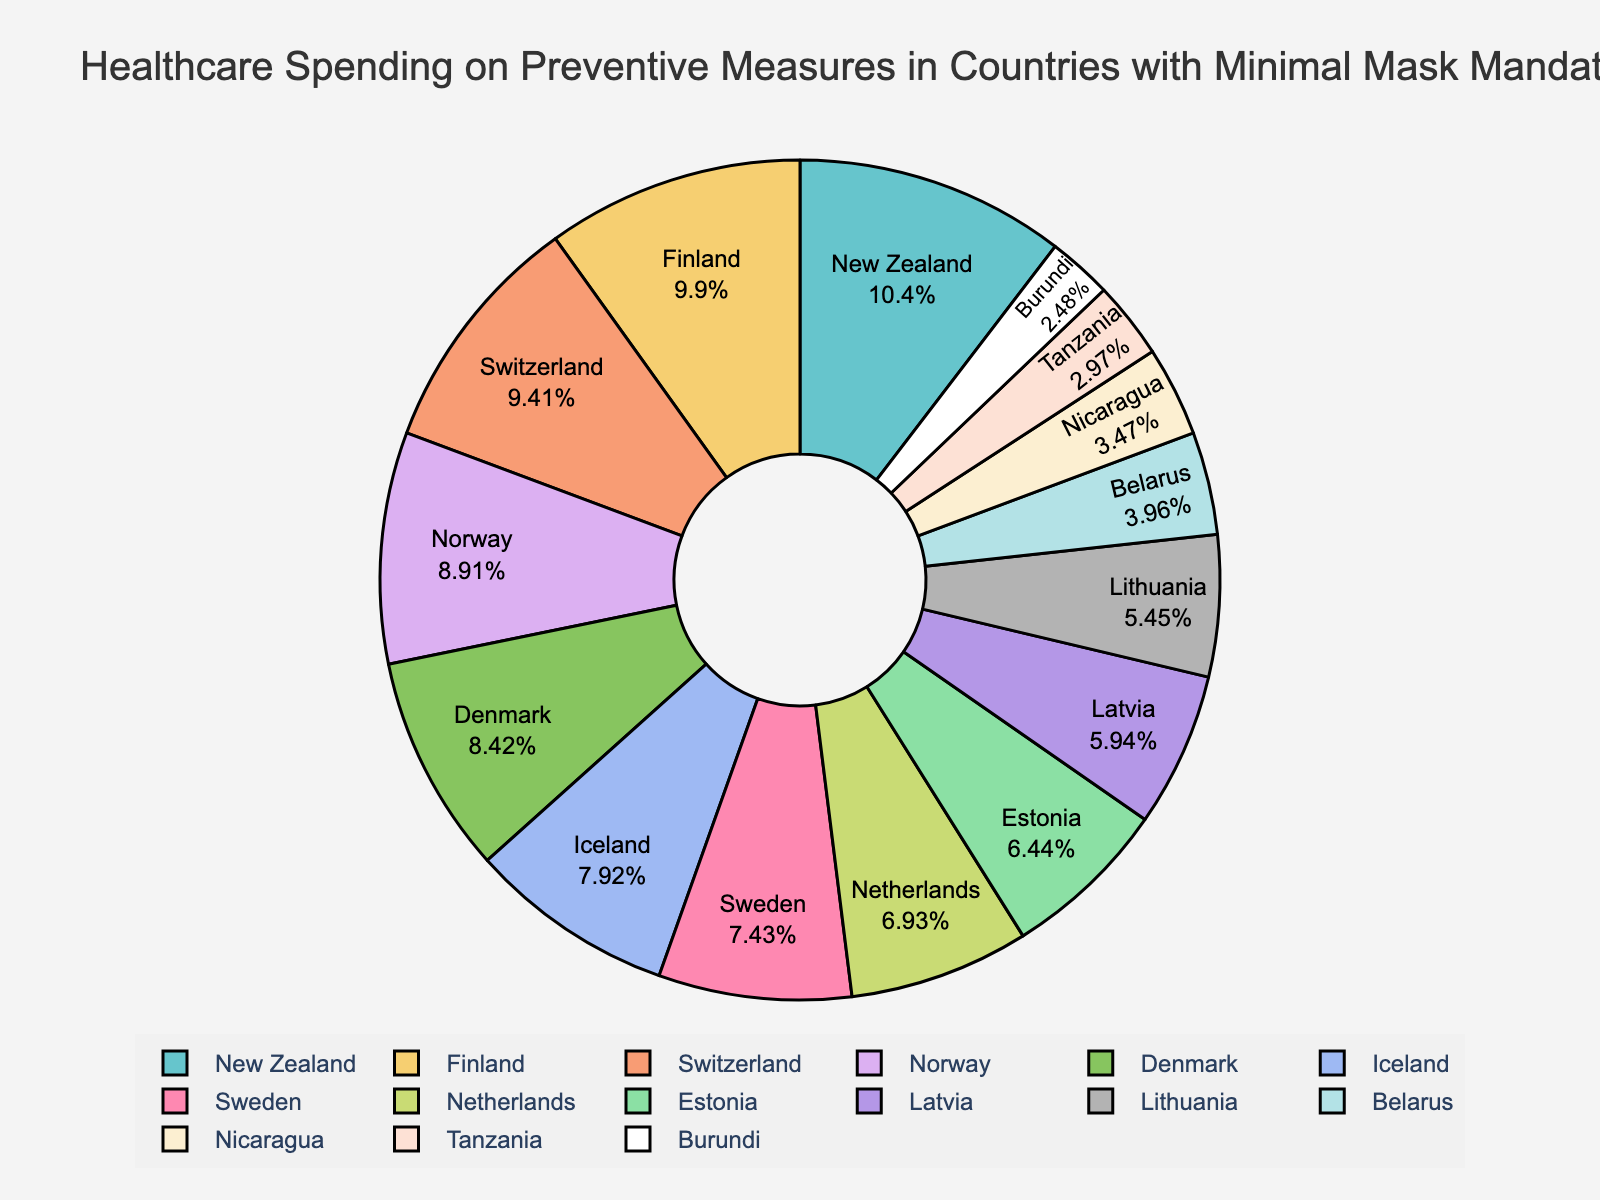What percentage of healthcare spending on preventive measures is allocated by Switzerland? Find Switzerland in the pie chart and read the percentage value displayed.
Answer: 19% Which country spends the least on preventive healthcare measures? Identify the country with the smallest slice in the pie chart and read its label.
Answer: Burundi What is the combined percentage of healthcare spending on preventive measures for the three countries with the highest allocations? Identify the three countries with the largest slices (New Zealand 21%, Finland 20%, Switzerland 19%), then add their percentages together: 21% + 20% + 19% = 60%.
Answer: 60% How does Norway's spending on preventive measures compare to the Netherlands' spending? Find Norway and the Netherlands in the pie chart, compare their percentages (18% for Norway and 14% for Netherlands). Norway spends a higher percentage.
Answer: Norway spends 4% more than the Netherlands Which country has a similar spending percentage to Iceland? Find Iceland in the chart (16%) and look for another country with a similar percentage. Denmark spends 17%, which is closest.
Answer: Denmark What is the average percentage allocation of the countries spending less than 10% on preventive measures? Identify the countries spending less than 10% (Belarus 8%, Tanzania 6%, Nicaragua 7%, Burundi 5%), then calculate the average: (8 + 6 + 7 + 5) / 4 = 6.5%.
Answer: 6.5% Is the spending on preventive measures by Denmark higher or lower than that of Sweden? Compare their slices in the pie chart: Denmark spends 17%, and Sweden spends 15%. Denmark spends more.
Answer: Higher What is the percentage difference in healthcare spending between Estonia and Latvia? Subtract Latvia's percentage from Estonia's (13% for Estonia and 12% for Latvia): 13% - 12% = 1%.
Answer: 1% Which countries have spending percentages within 1% of each other? Find countries with differences of 1% in their spending: Denmark (17%) and Iceland (16%), Finland (20%) and Switzerland (19%).
Answer: Denmark and Iceland; Finland and Switzerland 